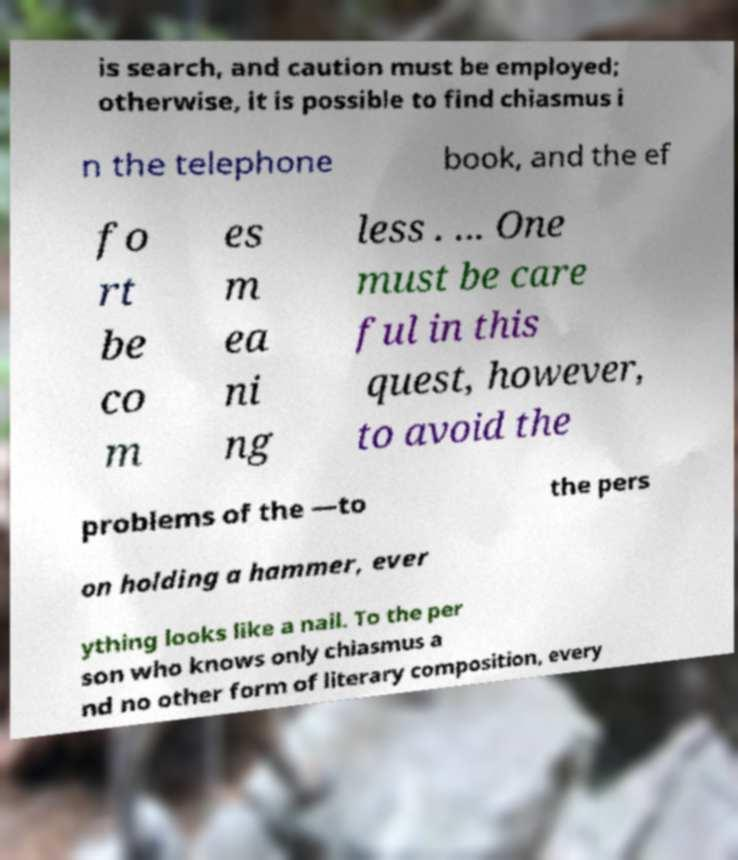There's text embedded in this image that I need extracted. Can you transcribe it verbatim? is search, and caution must be employed; otherwise, it is possible to find chiasmus i n the telephone book, and the ef fo rt be co m es m ea ni ng less . ... One must be care ful in this quest, however, to avoid the problems of the —to the pers on holding a hammer, ever ything looks like a nail. To the per son who knows only chiasmus a nd no other form of literary composition, every 